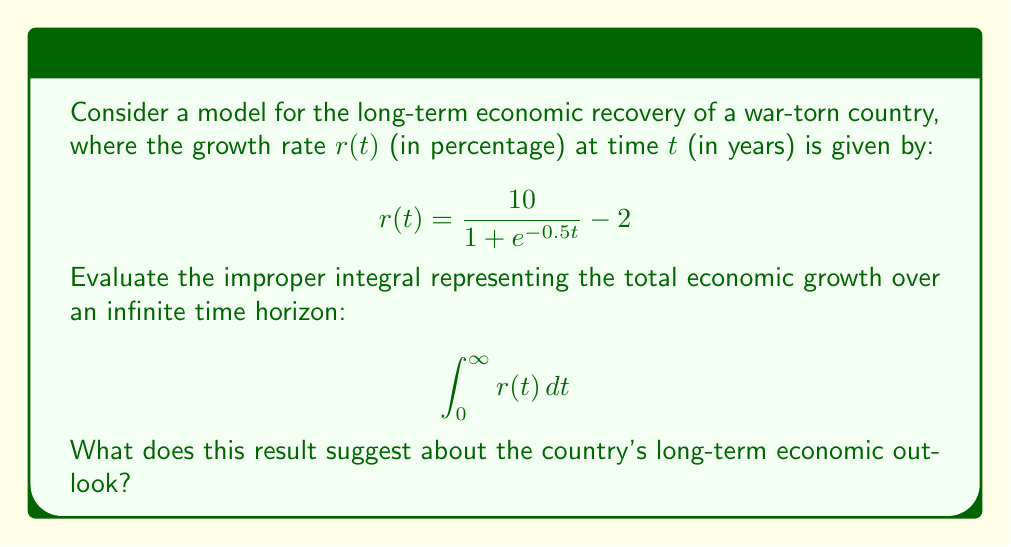Show me your answer to this math problem. Let's approach this step-by-step:

1) First, we need to evaluate the improper integral:
   $$\int_0^{\infty} r(t) \, dt = \int_0^{\infty} \left(\frac{10}{1 + e^{-0.5t}} - 2\right) \, dt$$

2) We can split this into two integrals:
   $$\int_0^{\infty} \frac{10}{1 + e^{-0.5t}} \, dt - \int_0^{\infty} 2 \, dt$$

3) The second integral diverges to $\infty$, so we need to focus on the first integral.

4) Let's substitute $u = e^{-0.5t}$. Then $du = -0.5e^{-0.5t} \, dt$, or $dt = -\frac{2}{u} \, du$.
   When $t = 0$, $u = 1$; when $t \to \infty$, $u \to 0$.

5) Applying this substitution:
   $$\int_1^0 \frac{10}{1 + u} \cdot \left(-\frac{2}{u}\right) \, du = 20 \int_0^1 \frac{1}{u(1+u)} \, du$$

6) This is a standard integral. Using partial fractions:
   $$20 \int_0^1 \left(\frac{1}{u} - \frac{1}{1+u}\right) \, du$$

7) Evaluating:
   $$20 [\ln|u| - \ln|1+u|]_0^1 = 20 [\ln(1) - \ln(2) - (\lim_{u \to 0} \ln(u) - \lim_{u \to 0} \ln(1+u))]$$

8) The limit as $u$ approaches 0 of $\ln(u)$ is $-\infty$, so this integral also diverges to $\infty$.

9) Since both parts of the original integral diverge to $\infty$, their difference is indeterminate.

This result suggests that the long-term economic outlook is uncertain. The positive growth terms and negative terms both grow without bound, indicating potential for both significant growth and significant challenges over time.
Answer: Indeterminate ($\infty - \infty$); long-term outlook uncertain. 